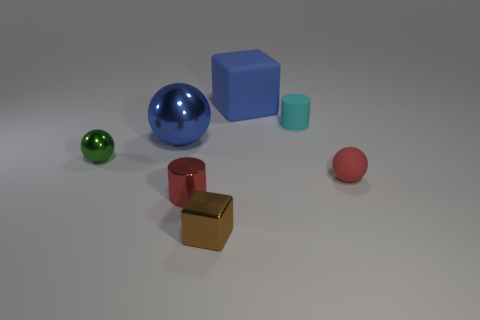There is a big object that is the same color as the large block; what shape is it?
Offer a terse response. Sphere. Is there anything else that has the same color as the big metal thing?
Make the answer very short. Yes. What size is the sphere on the right side of the cyan rubber object?
Offer a very short reply. Small. Are there more large red shiny cylinders than large balls?
Offer a terse response. No. What is the material of the large ball?
Provide a succinct answer. Metal. How many other things are made of the same material as the blue ball?
Offer a terse response. 3. How many red balls are there?
Keep it short and to the point. 1. There is another brown thing that is the same shape as the big matte thing; what is its material?
Your answer should be very brief. Metal. Do the large object left of the big blue rubber cube and the cyan cylinder have the same material?
Offer a very short reply. No. Are there more small brown shiny cubes that are on the left side of the red cylinder than large blue blocks behind the rubber cube?
Offer a terse response. No. 